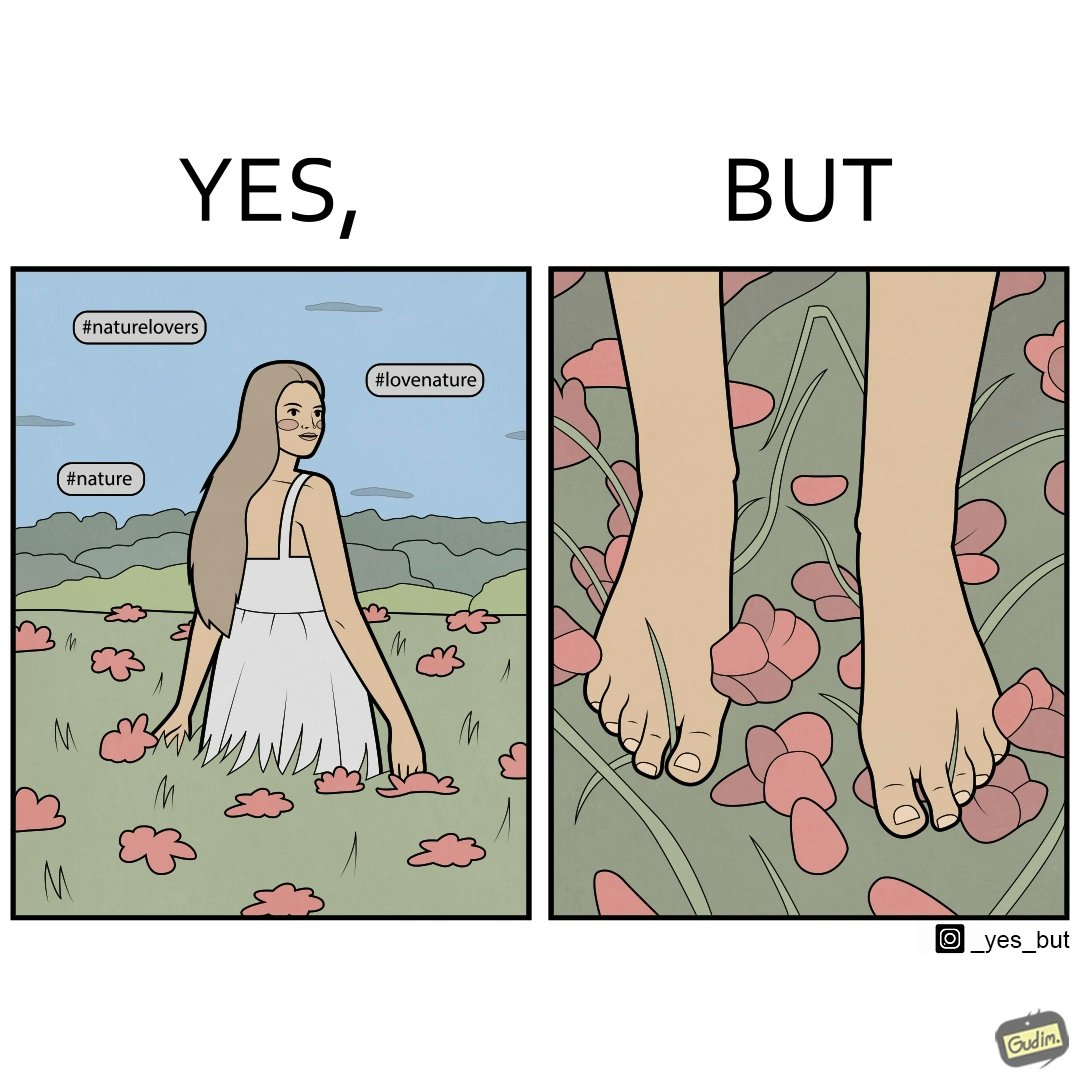Describe the contrast between the left and right parts of this image. In the left part of the image: a social media post showing a woman in a field of flowers, with hashtags such as #naturelovers, #lovenature, #nature. In the right part of the image: feet stepping on flower petals surrounded by grass. 